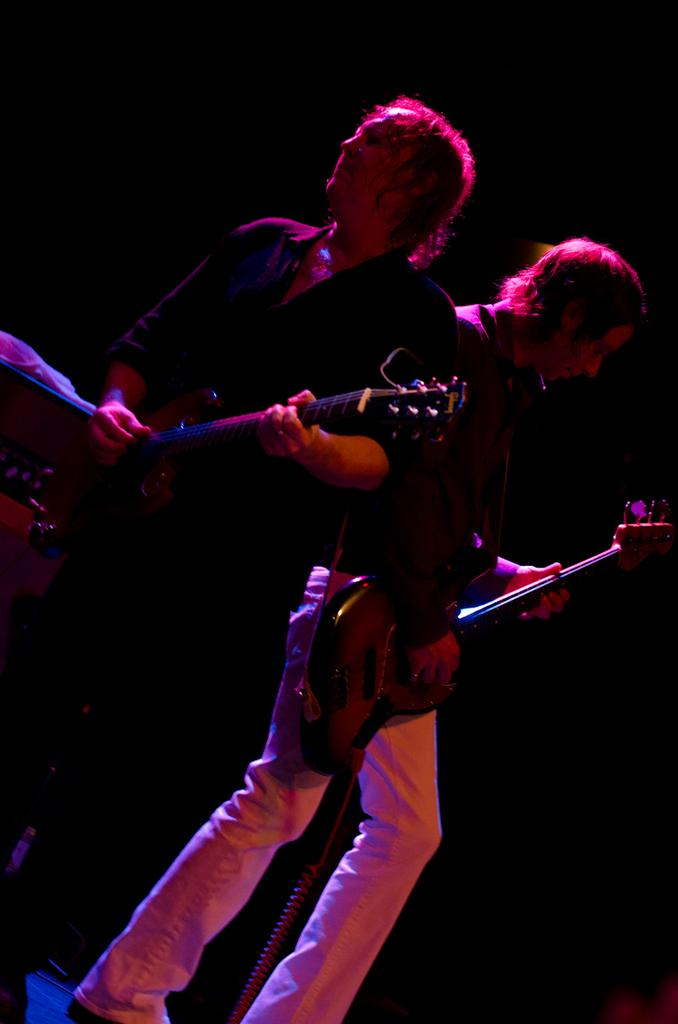How many people are present in the image? There are two people standing in the image. Can you describe the man on the right side of the image? The man on the right side of the image is holding a guitar and playing it. What is the other person doing in the image? The person on the left side of the image is also playing a guitar. What type of string is being used to transport the frog in the image? There is no frog or string present in the image, and therefore no such activity can be observed. 